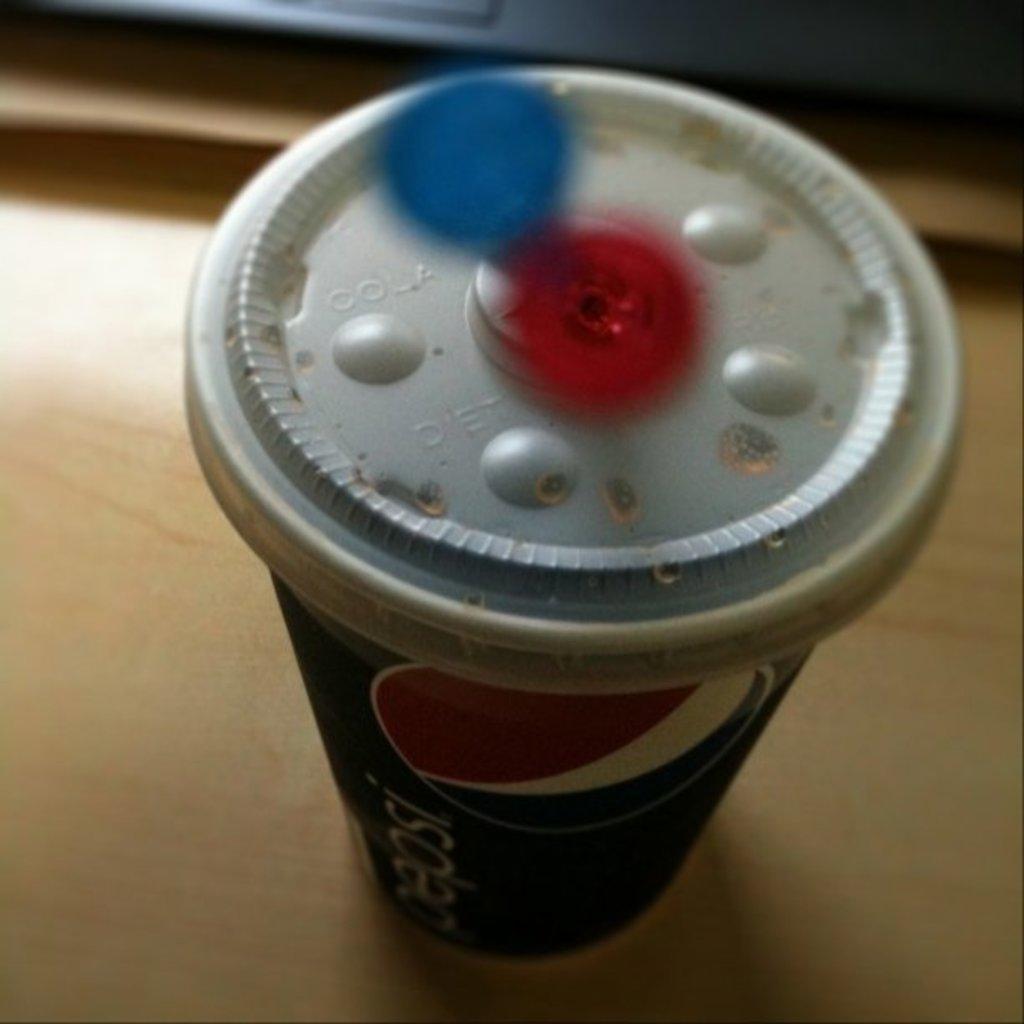Could you give a brief overview of what you see in this image? In this image I can see a disposal glass. In the background, I can see the table. 